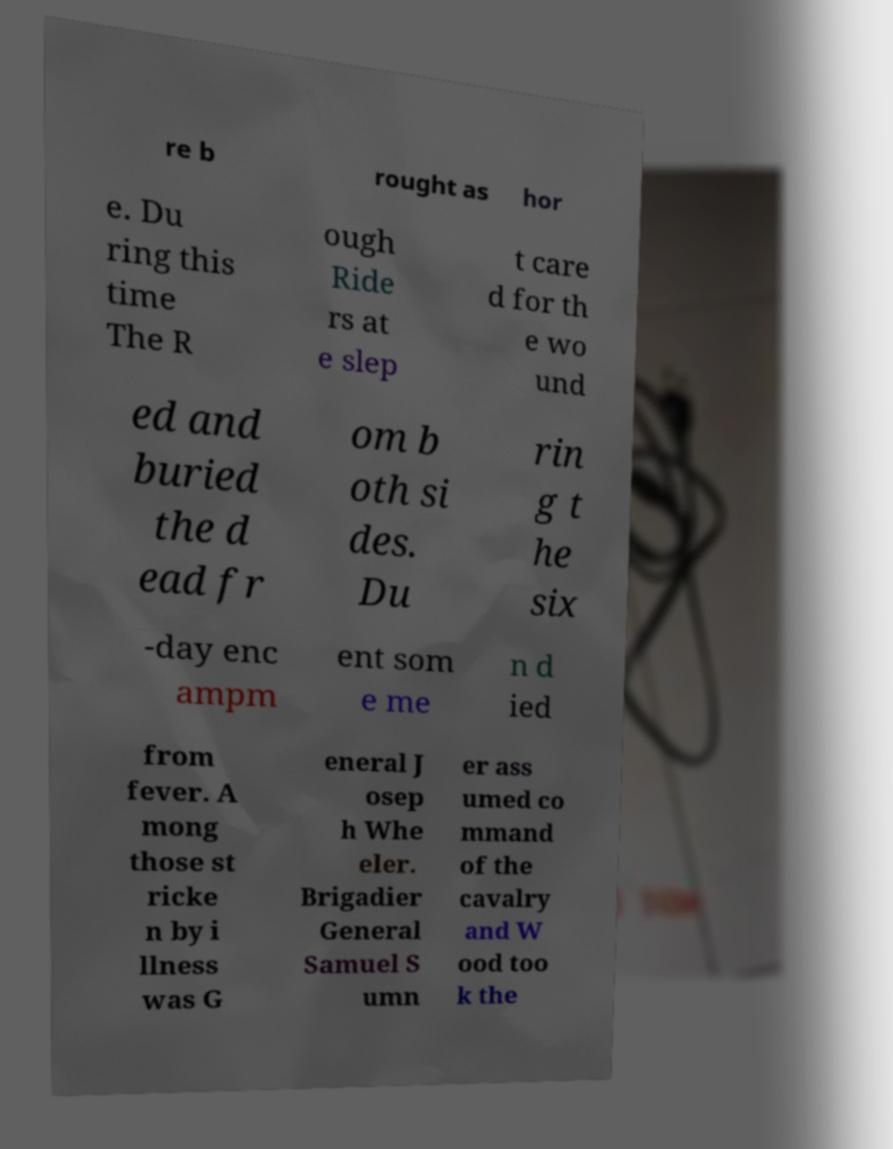Please read and relay the text visible in this image. What does it say? re b rought as hor e. Du ring this time The R ough Ride rs at e slep t care d for th e wo und ed and buried the d ead fr om b oth si des. Du rin g t he six -day enc ampm ent som e me n d ied from fever. A mong those st ricke n by i llness was G eneral J osep h Whe eler. Brigadier General Samuel S umn er ass umed co mmand of the cavalry and W ood too k the 